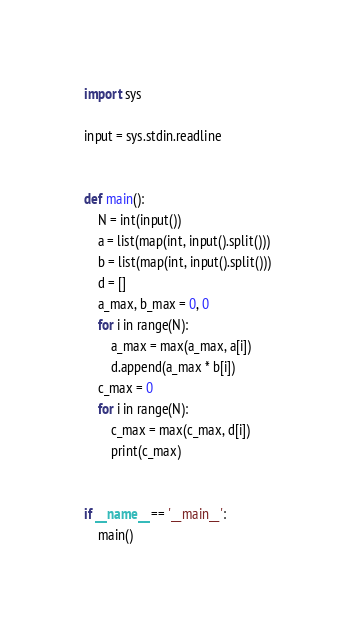<code> <loc_0><loc_0><loc_500><loc_500><_Python_>import sys

input = sys.stdin.readline


def main():
    N = int(input())
    a = list(map(int, input().split()))
    b = list(map(int, input().split()))
    d = []
    a_max, b_max = 0, 0
    for i in range(N):
        a_max = max(a_max, a[i])
        d.append(a_max * b[i])
    c_max = 0
    for i in range(N):
        c_max = max(c_max, d[i])
        print(c_max)


if __name__ == '__main__':
    main()</code> 